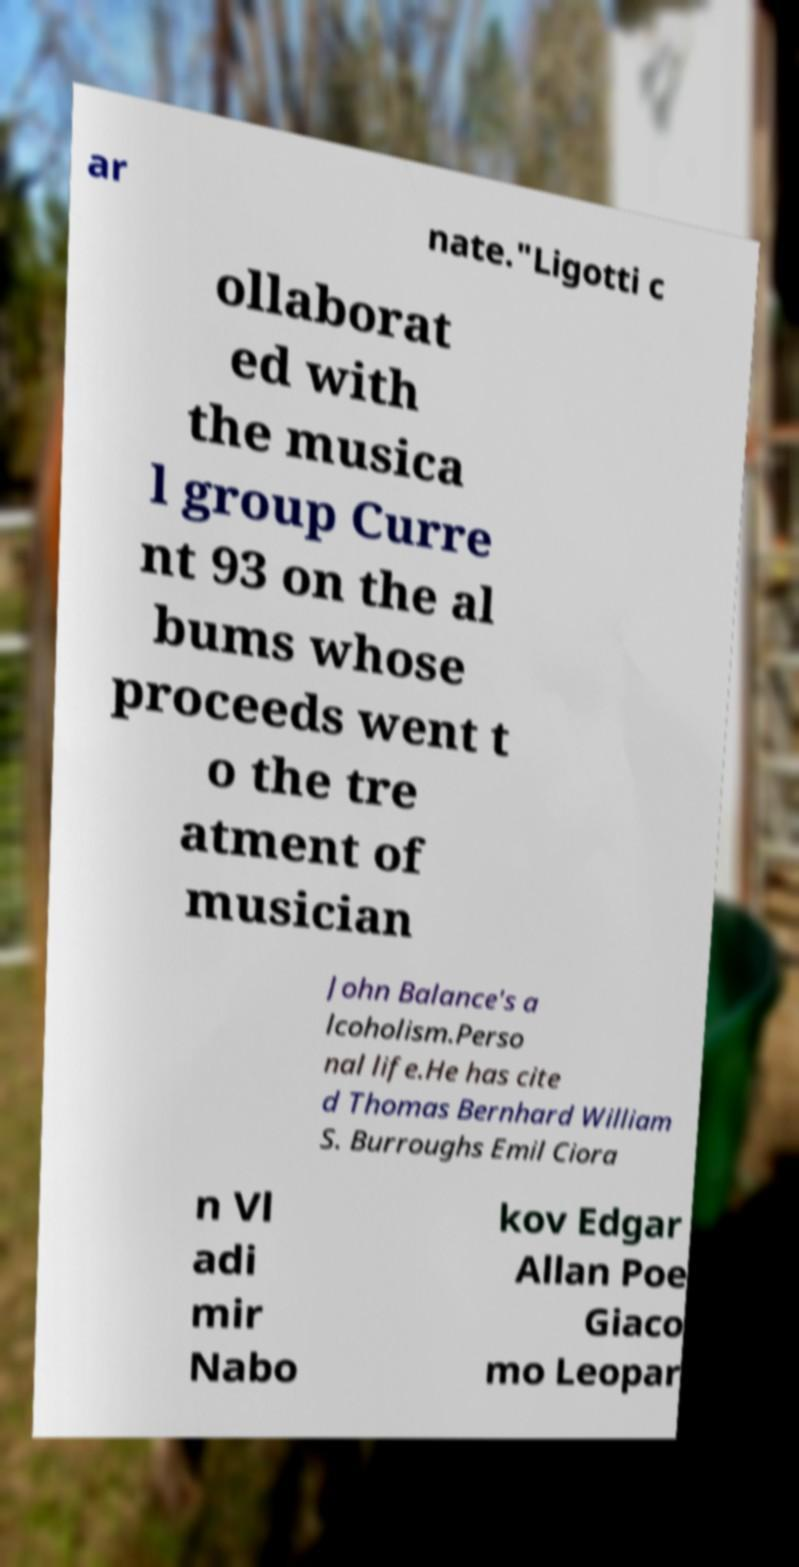Please identify and transcribe the text found in this image. ar nate."Ligotti c ollaborat ed with the musica l group Curre nt 93 on the al bums whose proceeds went t o the tre atment of musician John Balance's a lcoholism.Perso nal life.He has cite d Thomas Bernhard William S. Burroughs Emil Ciora n Vl adi mir Nabo kov Edgar Allan Poe Giaco mo Leopar 